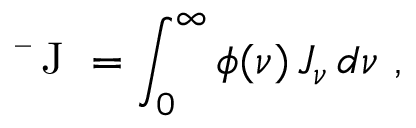<formula> <loc_0><loc_0><loc_500><loc_500>J = \int _ { 0 } ^ { \infty } \phi ( \nu ) \, J _ { \nu } \, d \nu \, ,</formula> 